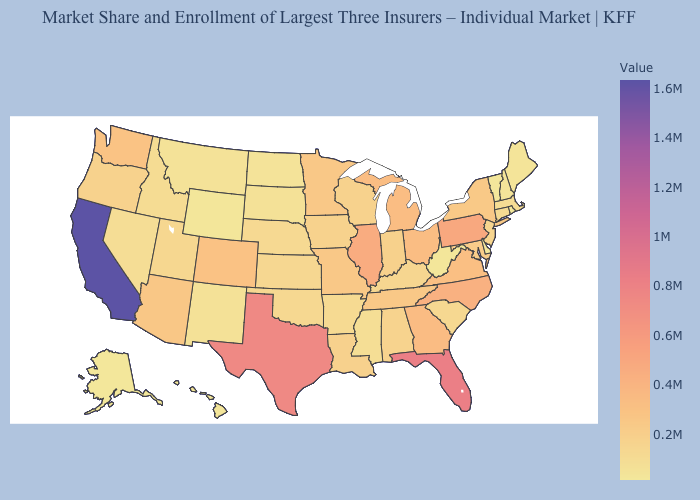Does the map have missing data?
Write a very short answer. No. Does North Carolina have the highest value in the USA?
Concise answer only. No. Which states have the highest value in the USA?
Concise answer only. California. Does California have the highest value in the USA?
Short answer required. Yes. 